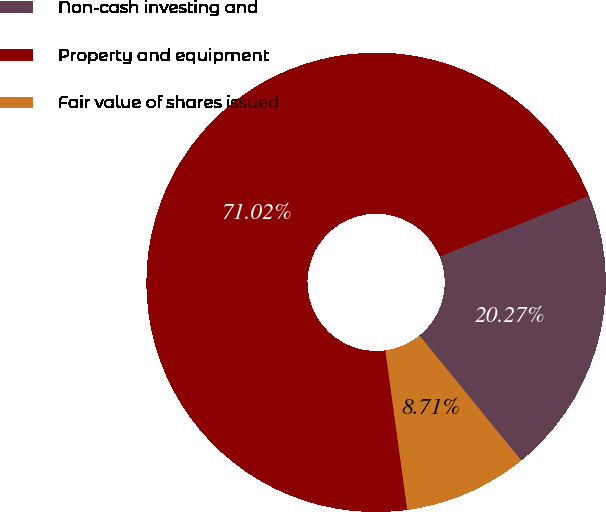Convert chart. <chart><loc_0><loc_0><loc_500><loc_500><pie_chart><fcel>Non-cash investing and<fcel>Property and equipment<fcel>Fair value of shares issued<nl><fcel>20.27%<fcel>71.02%<fcel>8.71%<nl></chart> 